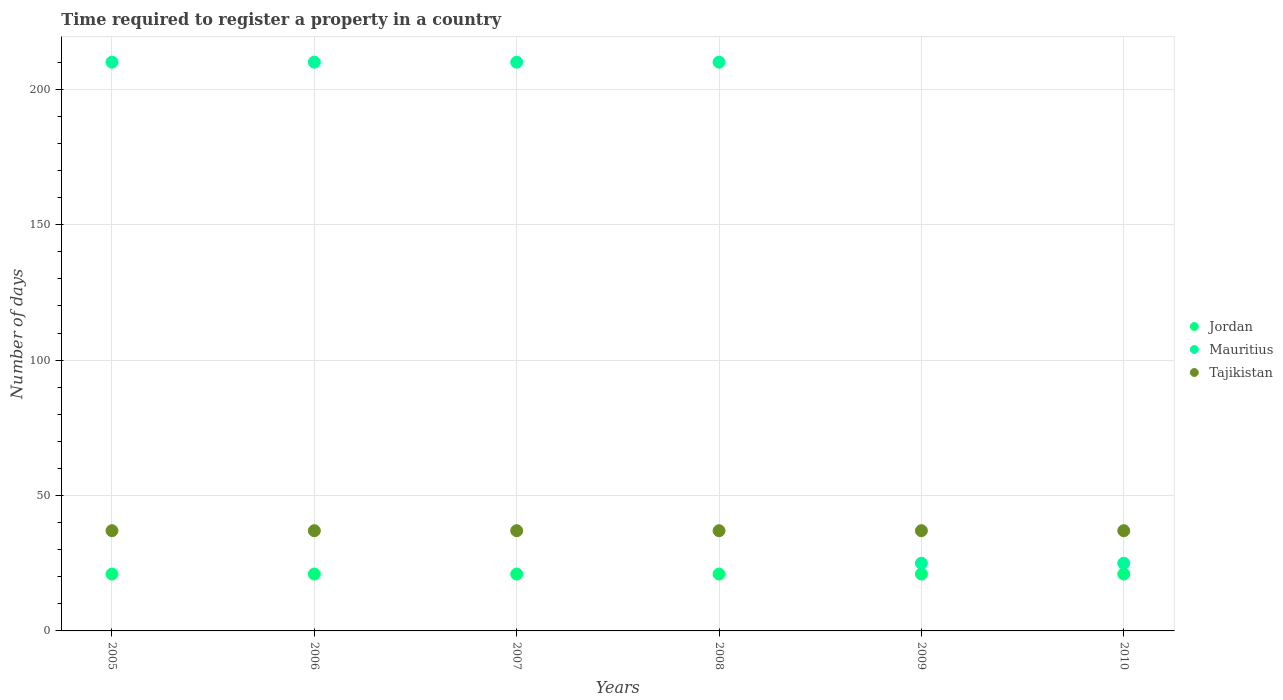How many different coloured dotlines are there?
Ensure brevity in your answer.  3. What is the number of days required to register a property in Mauritius in 2010?
Offer a terse response. 25. Across all years, what is the maximum number of days required to register a property in Jordan?
Your response must be concise. 21. Across all years, what is the minimum number of days required to register a property in Mauritius?
Offer a very short reply. 25. In which year was the number of days required to register a property in Tajikistan minimum?
Give a very brief answer. 2005. What is the total number of days required to register a property in Mauritius in the graph?
Offer a terse response. 890. In the year 2007, what is the difference between the number of days required to register a property in Mauritius and number of days required to register a property in Tajikistan?
Ensure brevity in your answer.  173. Is the number of days required to register a property in Tajikistan in 2005 less than that in 2008?
Your response must be concise. No. In how many years, is the number of days required to register a property in Tajikistan greater than the average number of days required to register a property in Tajikistan taken over all years?
Provide a short and direct response. 0. Is the sum of the number of days required to register a property in Tajikistan in 2006 and 2010 greater than the maximum number of days required to register a property in Jordan across all years?
Make the answer very short. Yes. Is it the case that in every year, the sum of the number of days required to register a property in Tajikistan and number of days required to register a property in Mauritius  is greater than the number of days required to register a property in Jordan?
Your answer should be very brief. Yes. Is the number of days required to register a property in Jordan strictly less than the number of days required to register a property in Tajikistan over the years?
Provide a short and direct response. Yes. How many dotlines are there?
Provide a succinct answer. 3. How many years are there in the graph?
Provide a short and direct response. 6. What is the difference between two consecutive major ticks on the Y-axis?
Offer a terse response. 50. Where does the legend appear in the graph?
Offer a very short reply. Center right. How many legend labels are there?
Provide a short and direct response. 3. What is the title of the graph?
Give a very brief answer. Time required to register a property in a country. Does "Samoa" appear as one of the legend labels in the graph?
Provide a succinct answer. No. What is the label or title of the Y-axis?
Give a very brief answer. Number of days. What is the Number of days in Jordan in 2005?
Make the answer very short. 21. What is the Number of days of Mauritius in 2005?
Ensure brevity in your answer.  210. What is the Number of days of Tajikistan in 2005?
Your answer should be very brief. 37. What is the Number of days in Jordan in 2006?
Your answer should be compact. 21. What is the Number of days of Mauritius in 2006?
Make the answer very short. 210. What is the Number of days of Tajikistan in 2006?
Make the answer very short. 37. What is the Number of days of Jordan in 2007?
Your response must be concise. 21. What is the Number of days in Mauritius in 2007?
Ensure brevity in your answer.  210. What is the Number of days in Jordan in 2008?
Offer a very short reply. 21. What is the Number of days in Mauritius in 2008?
Your answer should be very brief. 210. What is the Number of days in Mauritius in 2009?
Make the answer very short. 25. What is the Number of days in Mauritius in 2010?
Give a very brief answer. 25. What is the Number of days in Tajikistan in 2010?
Your answer should be compact. 37. Across all years, what is the maximum Number of days in Jordan?
Provide a short and direct response. 21. Across all years, what is the maximum Number of days of Mauritius?
Offer a terse response. 210. Across all years, what is the maximum Number of days in Tajikistan?
Provide a succinct answer. 37. Across all years, what is the minimum Number of days of Jordan?
Give a very brief answer. 21. Across all years, what is the minimum Number of days of Tajikistan?
Ensure brevity in your answer.  37. What is the total Number of days in Jordan in the graph?
Offer a terse response. 126. What is the total Number of days of Mauritius in the graph?
Make the answer very short. 890. What is the total Number of days in Tajikistan in the graph?
Provide a short and direct response. 222. What is the difference between the Number of days of Jordan in 2005 and that in 2007?
Your answer should be very brief. 0. What is the difference between the Number of days of Tajikistan in 2005 and that in 2007?
Give a very brief answer. 0. What is the difference between the Number of days in Mauritius in 2005 and that in 2008?
Ensure brevity in your answer.  0. What is the difference between the Number of days in Tajikistan in 2005 and that in 2008?
Keep it short and to the point. 0. What is the difference between the Number of days of Mauritius in 2005 and that in 2009?
Keep it short and to the point. 185. What is the difference between the Number of days in Tajikistan in 2005 and that in 2009?
Your answer should be compact. 0. What is the difference between the Number of days in Mauritius in 2005 and that in 2010?
Offer a very short reply. 185. What is the difference between the Number of days in Jordan in 2006 and that in 2008?
Offer a terse response. 0. What is the difference between the Number of days of Mauritius in 2006 and that in 2008?
Ensure brevity in your answer.  0. What is the difference between the Number of days of Tajikistan in 2006 and that in 2008?
Provide a succinct answer. 0. What is the difference between the Number of days of Jordan in 2006 and that in 2009?
Provide a succinct answer. 0. What is the difference between the Number of days of Mauritius in 2006 and that in 2009?
Provide a short and direct response. 185. What is the difference between the Number of days in Mauritius in 2006 and that in 2010?
Provide a succinct answer. 185. What is the difference between the Number of days of Jordan in 2007 and that in 2008?
Offer a very short reply. 0. What is the difference between the Number of days of Jordan in 2007 and that in 2009?
Provide a succinct answer. 0. What is the difference between the Number of days in Mauritius in 2007 and that in 2009?
Ensure brevity in your answer.  185. What is the difference between the Number of days in Tajikistan in 2007 and that in 2009?
Offer a very short reply. 0. What is the difference between the Number of days in Jordan in 2007 and that in 2010?
Provide a succinct answer. 0. What is the difference between the Number of days of Mauritius in 2007 and that in 2010?
Your answer should be very brief. 185. What is the difference between the Number of days in Mauritius in 2008 and that in 2009?
Give a very brief answer. 185. What is the difference between the Number of days of Tajikistan in 2008 and that in 2009?
Offer a terse response. 0. What is the difference between the Number of days of Mauritius in 2008 and that in 2010?
Ensure brevity in your answer.  185. What is the difference between the Number of days of Tajikistan in 2008 and that in 2010?
Give a very brief answer. 0. What is the difference between the Number of days in Mauritius in 2009 and that in 2010?
Offer a terse response. 0. What is the difference between the Number of days in Jordan in 2005 and the Number of days in Mauritius in 2006?
Offer a very short reply. -189. What is the difference between the Number of days of Mauritius in 2005 and the Number of days of Tajikistan in 2006?
Ensure brevity in your answer.  173. What is the difference between the Number of days in Jordan in 2005 and the Number of days in Mauritius in 2007?
Keep it short and to the point. -189. What is the difference between the Number of days of Jordan in 2005 and the Number of days of Tajikistan in 2007?
Your response must be concise. -16. What is the difference between the Number of days of Mauritius in 2005 and the Number of days of Tajikistan in 2007?
Your answer should be compact. 173. What is the difference between the Number of days in Jordan in 2005 and the Number of days in Mauritius in 2008?
Offer a terse response. -189. What is the difference between the Number of days in Jordan in 2005 and the Number of days in Tajikistan in 2008?
Give a very brief answer. -16. What is the difference between the Number of days of Mauritius in 2005 and the Number of days of Tajikistan in 2008?
Keep it short and to the point. 173. What is the difference between the Number of days of Jordan in 2005 and the Number of days of Mauritius in 2009?
Keep it short and to the point. -4. What is the difference between the Number of days of Mauritius in 2005 and the Number of days of Tajikistan in 2009?
Offer a terse response. 173. What is the difference between the Number of days of Mauritius in 2005 and the Number of days of Tajikistan in 2010?
Your answer should be very brief. 173. What is the difference between the Number of days of Jordan in 2006 and the Number of days of Mauritius in 2007?
Offer a very short reply. -189. What is the difference between the Number of days in Mauritius in 2006 and the Number of days in Tajikistan in 2007?
Offer a terse response. 173. What is the difference between the Number of days in Jordan in 2006 and the Number of days in Mauritius in 2008?
Provide a short and direct response. -189. What is the difference between the Number of days in Mauritius in 2006 and the Number of days in Tajikistan in 2008?
Your answer should be very brief. 173. What is the difference between the Number of days in Mauritius in 2006 and the Number of days in Tajikistan in 2009?
Give a very brief answer. 173. What is the difference between the Number of days of Jordan in 2006 and the Number of days of Tajikistan in 2010?
Provide a short and direct response. -16. What is the difference between the Number of days in Mauritius in 2006 and the Number of days in Tajikistan in 2010?
Make the answer very short. 173. What is the difference between the Number of days in Jordan in 2007 and the Number of days in Mauritius in 2008?
Offer a terse response. -189. What is the difference between the Number of days of Mauritius in 2007 and the Number of days of Tajikistan in 2008?
Offer a very short reply. 173. What is the difference between the Number of days of Jordan in 2007 and the Number of days of Tajikistan in 2009?
Provide a short and direct response. -16. What is the difference between the Number of days in Mauritius in 2007 and the Number of days in Tajikistan in 2009?
Offer a very short reply. 173. What is the difference between the Number of days of Mauritius in 2007 and the Number of days of Tajikistan in 2010?
Your answer should be very brief. 173. What is the difference between the Number of days in Jordan in 2008 and the Number of days in Mauritius in 2009?
Your answer should be compact. -4. What is the difference between the Number of days in Jordan in 2008 and the Number of days in Tajikistan in 2009?
Provide a succinct answer. -16. What is the difference between the Number of days in Mauritius in 2008 and the Number of days in Tajikistan in 2009?
Provide a short and direct response. 173. What is the difference between the Number of days of Jordan in 2008 and the Number of days of Mauritius in 2010?
Your answer should be very brief. -4. What is the difference between the Number of days of Jordan in 2008 and the Number of days of Tajikistan in 2010?
Keep it short and to the point. -16. What is the difference between the Number of days in Mauritius in 2008 and the Number of days in Tajikistan in 2010?
Make the answer very short. 173. What is the difference between the Number of days in Jordan in 2009 and the Number of days in Mauritius in 2010?
Your answer should be very brief. -4. What is the average Number of days of Mauritius per year?
Your answer should be compact. 148.33. In the year 2005, what is the difference between the Number of days of Jordan and Number of days of Mauritius?
Ensure brevity in your answer.  -189. In the year 2005, what is the difference between the Number of days of Jordan and Number of days of Tajikistan?
Keep it short and to the point. -16. In the year 2005, what is the difference between the Number of days of Mauritius and Number of days of Tajikistan?
Offer a terse response. 173. In the year 2006, what is the difference between the Number of days of Jordan and Number of days of Mauritius?
Ensure brevity in your answer.  -189. In the year 2006, what is the difference between the Number of days of Jordan and Number of days of Tajikistan?
Your answer should be compact. -16. In the year 2006, what is the difference between the Number of days of Mauritius and Number of days of Tajikistan?
Give a very brief answer. 173. In the year 2007, what is the difference between the Number of days in Jordan and Number of days in Mauritius?
Your response must be concise. -189. In the year 2007, what is the difference between the Number of days of Mauritius and Number of days of Tajikistan?
Keep it short and to the point. 173. In the year 2008, what is the difference between the Number of days in Jordan and Number of days in Mauritius?
Keep it short and to the point. -189. In the year 2008, what is the difference between the Number of days of Jordan and Number of days of Tajikistan?
Keep it short and to the point. -16. In the year 2008, what is the difference between the Number of days of Mauritius and Number of days of Tajikistan?
Your answer should be very brief. 173. What is the ratio of the Number of days in Tajikistan in 2005 to that in 2006?
Give a very brief answer. 1. What is the ratio of the Number of days in Mauritius in 2005 to that in 2007?
Offer a terse response. 1. What is the ratio of the Number of days in Tajikistan in 2005 to that in 2007?
Your answer should be compact. 1. What is the ratio of the Number of days in Jordan in 2005 to that in 2008?
Provide a short and direct response. 1. What is the ratio of the Number of days in Mauritius in 2005 to that in 2008?
Keep it short and to the point. 1. What is the ratio of the Number of days in Tajikistan in 2005 to that in 2008?
Give a very brief answer. 1. What is the ratio of the Number of days in Jordan in 2005 to that in 2009?
Ensure brevity in your answer.  1. What is the ratio of the Number of days of Tajikistan in 2005 to that in 2009?
Your answer should be compact. 1. What is the ratio of the Number of days of Mauritius in 2005 to that in 2010?
Make the answer very short. 8.4. What is the ratio of the Number of days in Tajikistan in 2005 to that in 2010?
Offer a terse response. 1. What is the ratio of the Number of days in Jordan in 2006 to that in 2007?
Make the answer very short. 1. What is the ratio of the Number of days of Tajikistan in 2006 to that in 2007?
Ensure brevity in your answer.  1. What is the ratio of the Number of days of Jordan in 2006 to that in 2008?
Provide a succinct answer. 1. What is the ratio of the Number of days in Mauritius in 2006 to that in 2008?
Give a very brief answer. 1. What is the ratio of the Number of days of Tajikistan in 2006 to that in 2008?
Offer a very short reply. 1. What is the ratio of the Number of days in Mauritius in 2006 to that in 2009?
Give a very brief answer. 8.4. What is the ratio of the Number of days in Jordan in 2006 to that in 2010?
Make the answer very short. 1. What is the ratio of the Number of days in Mauritius in 2006 to that in 2010?
Your answer should be compact. 8.4. What is the ratio of the Number of days of Tajikistan in 2006 to that in 2010?
Your answer should be compact. 1. What is the ratio of the Number of days in Mauritius in 2007 to that in 2008?
Give a very brief answer. 1. What is the ratio of the Number of days in Tajikistan in 2007 to that in 2008?
Your answer should be compact. 1. What is the ratio of the Number of days of Mauritius in 2007 to that in 2009?
Your answer should be compact. 8.4. What is the ratio of the Number of days in Tajikistan in 2007 to that in 2010?
Provide a succinct answer. 1. What is the ratio of the Number of days in Jordan in 2008 to that in 2010?
Offer a terse response. 1. What is the ratio of the Number of days of Tajikistan in 2008 to that in 2010?
Provide a short and direct response. 1. What is the ratio of the Number of days of Mauritius in 2009 to that in 2010?
Ensure brevity in your answer.  1. What is the difference between the highest and the lowest Number of days in Jordan?
Keep it short and to the point. 0. What is the difference between the highest and the lowest Number of days of Mauritius?
Ensure brevity in your answer.  185. What is the difference between the highest and the lowest Number of days of Tajikistan?
Keep it short and to the point. 0. 